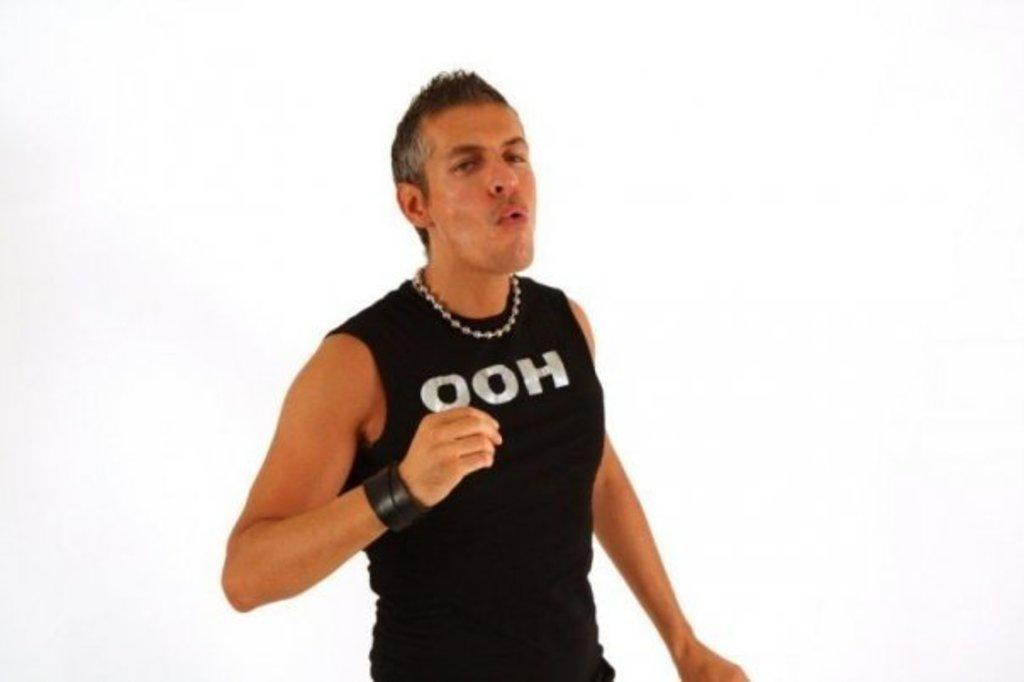<image>
Share a concise interpretation of the image provided. A man wearing a sleeveless black shirt the says OOH on it. 